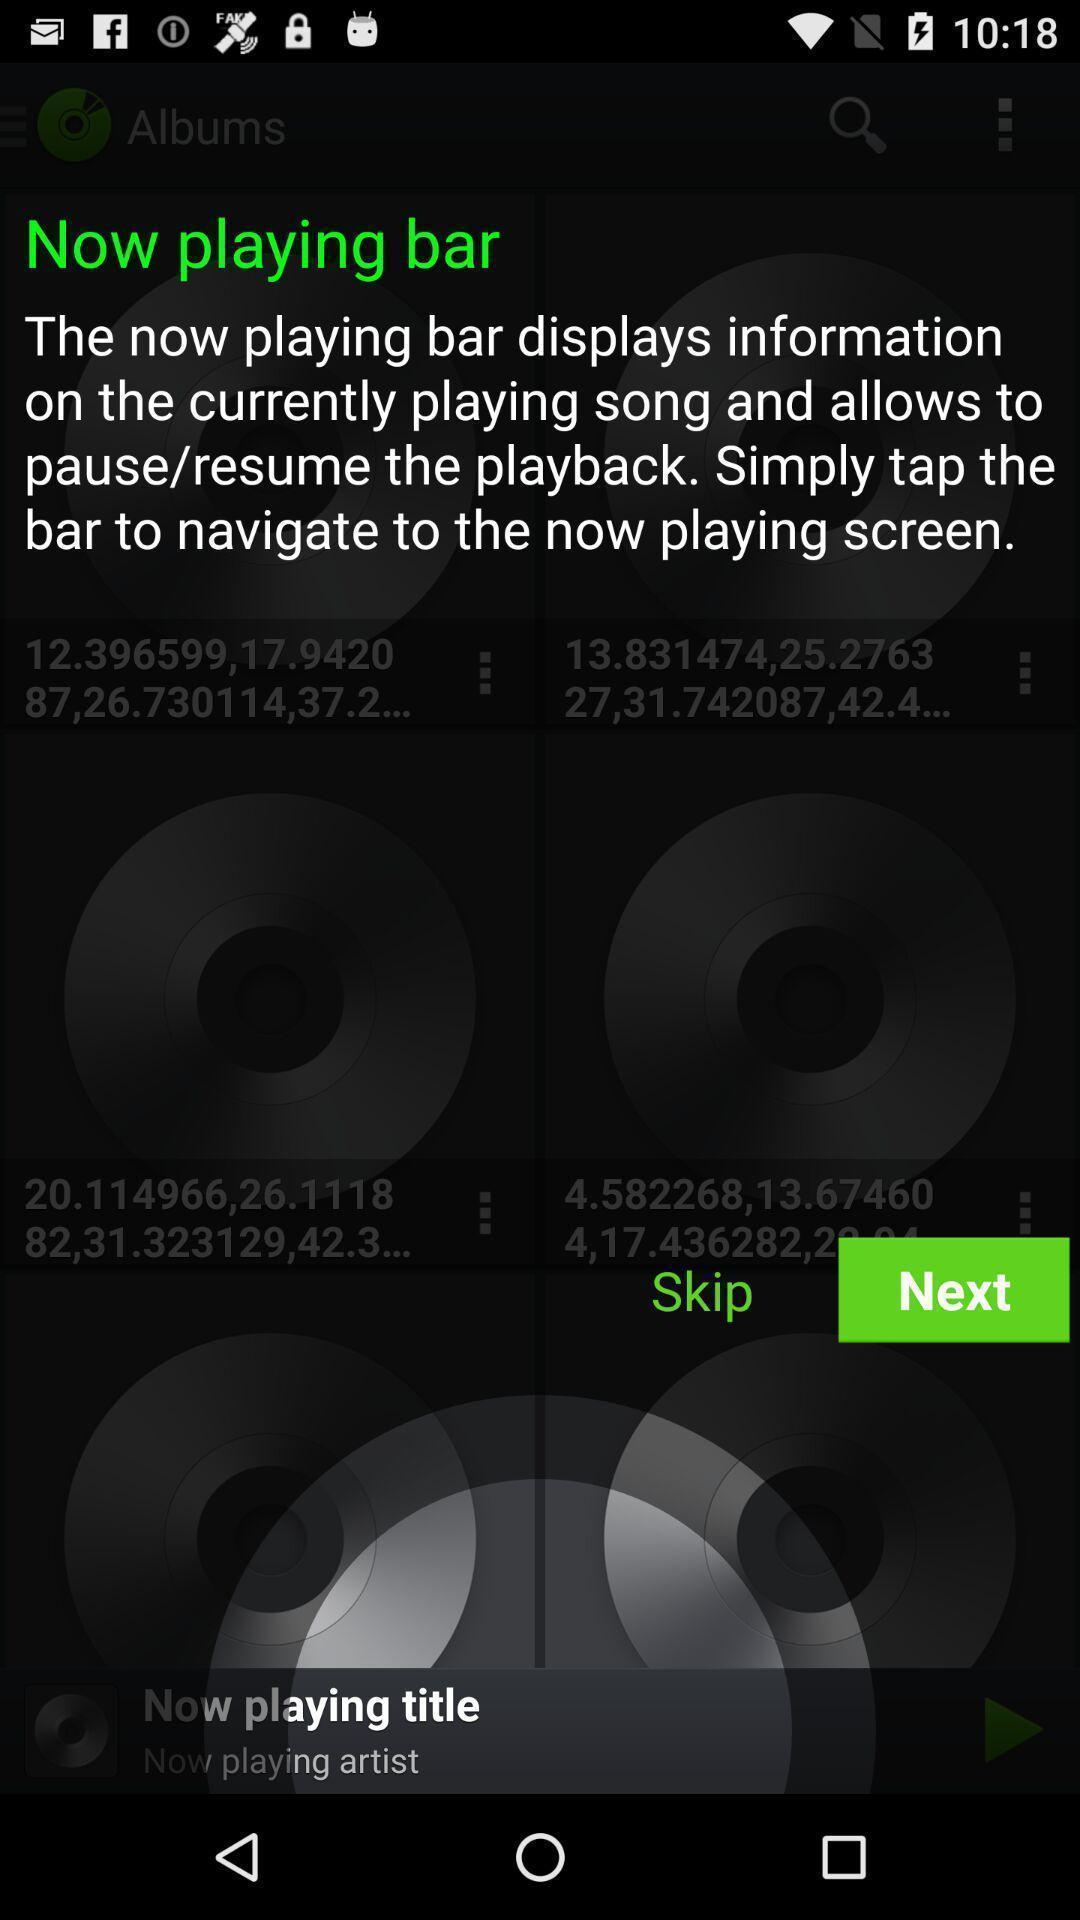Tell me what you see in this picture. Pop-up of a permission about resume/pause the playback. 